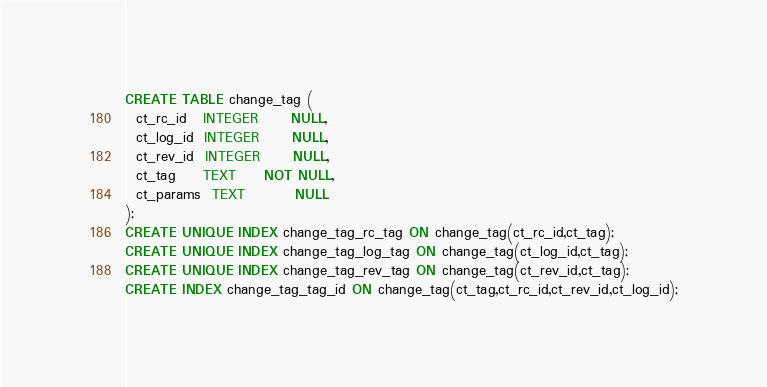Convert code to text. <code><loc_0><loc_0><loc_500><loc_500><_SQL_>CREATE TABLE change_tag (
  ct_rc_id   INTEGER      NULL,
  ct_log_id  INTEGER      NULL,
  ct_rev_id  INTEGER      NULL,
  ct_tag     TEXT     NOT NULL,
  ct_params  TEXT         NULL
);
CREATE UNIQUE INDEX change_tag_rc_tag ON change_tag(ct_rc_id,ct_tag);
CREATE UNIQUE INDEX change_tag_log_tag ON change_tag(ct_log_id,ct_tag);
CREATE UNIQUE INDEX change_tag_rev_tag ON change_tag(ct_rev_id,ct_tag);
CREATE INDEX change_tag_tag_id ON change_tag(ct_tag,ct_rc_id,ct_rev_id,ct_log_id);
</code> 